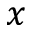<formula> <loc_0><loc_0><loc_500><loc_500>x</formula> 